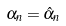<formula> <loc_0><loc_0><loc_500><loc_500>\alpha _ { n } = \hat { \alpha } _ { n }</formula> 